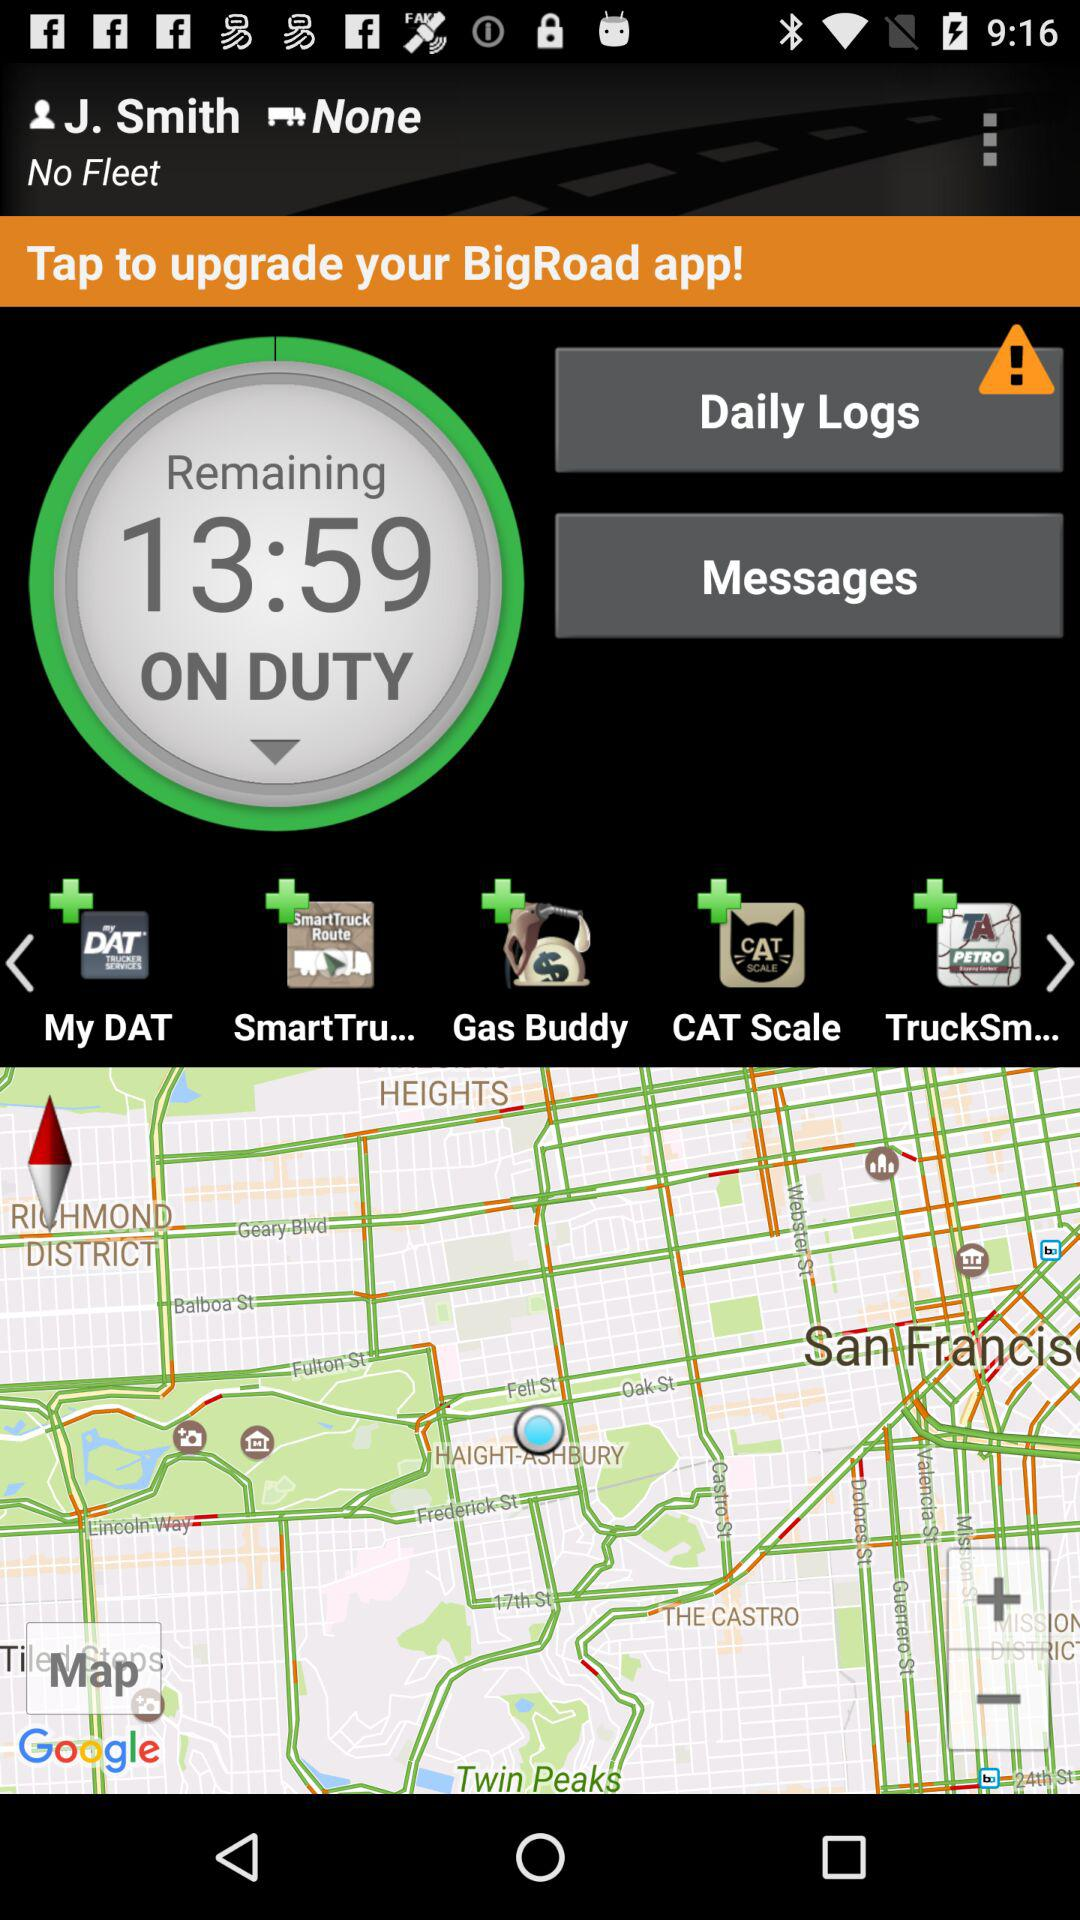What is the user name? The user name is J. Smith. 